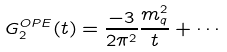<formula> <loc_0><loc_0><loc_500><loc_500>G ^ { O P E } _ { 2 } ( t ) = \frac { - 3 } { 2 \pi ^ { 2 } } \frac { m _ { q } ^ { 2 } } { t } + \cdots</formula> 